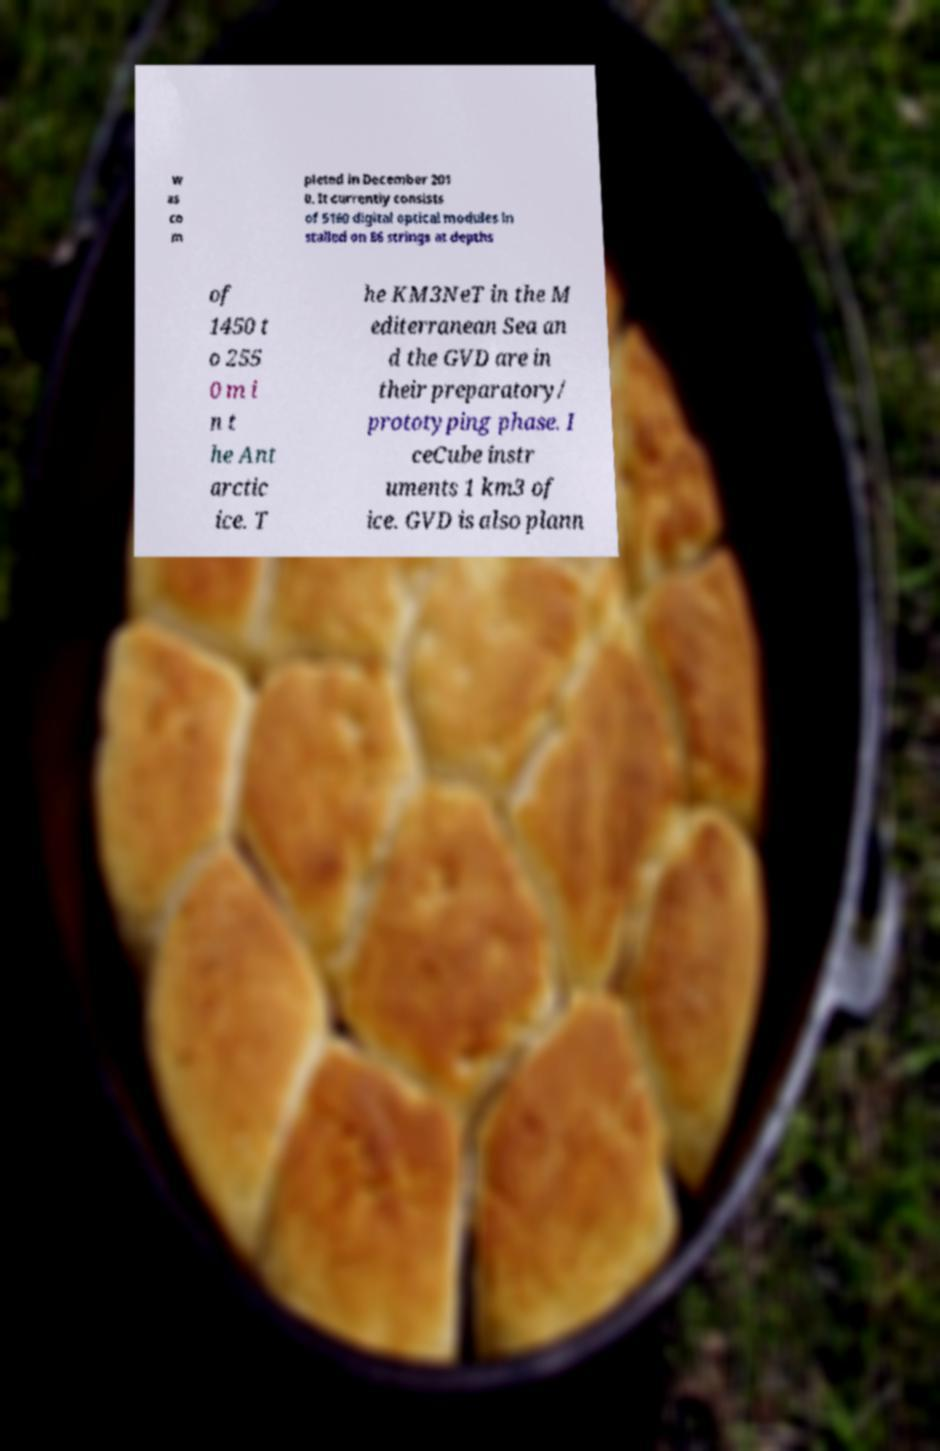Please read and relay the text visible in this image. What does it say? w as co m pleted in December 201 0. It currently consists of 5160 digital optical modules in stalled on 86 strings at depths of 1450 t o 255 0 m i n t he Ant arctic ice. T he KM3NeT in the M editerranean Sea an d the GVD are in their preparatory/ prototyping phase. I ceCube instr uments 1 km3 of ice. GVD is also plann 